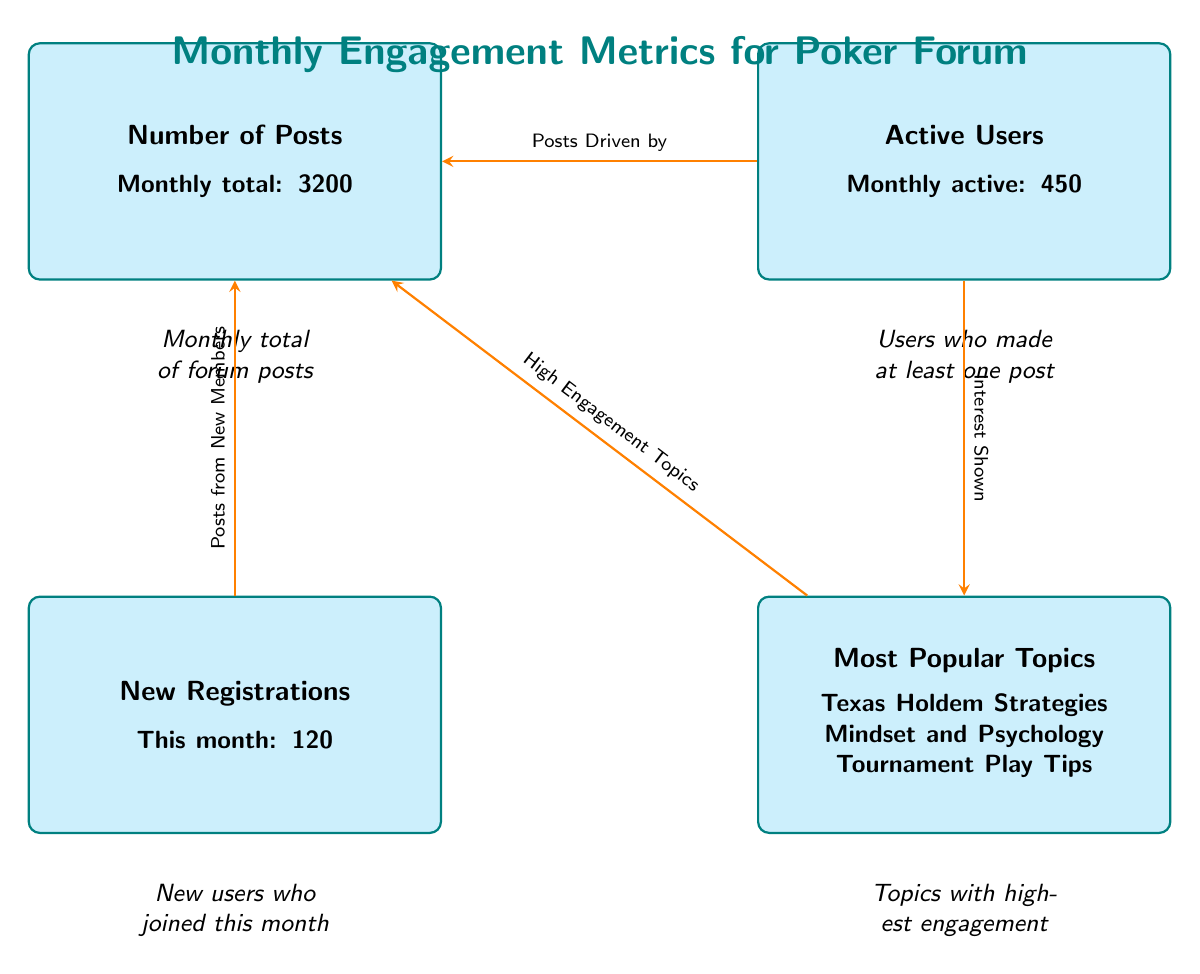What is the monthly total number of forum posts? The diagram states that the total number of posts is explicitly mentioned as "Monthly total: 3200" under the Number of Posts node.
Answer: 3200 How many active users participated this month? Under the Active Users node, it is clearly stated "Monthly active: 450," indicating the number of users who made posts.
Answer: 450 How many new registrations were reported this month? The New Registrations node shows "This month: 120," which provides the specific count of new members who joined the forum.
Answer: 120 What are the most popular topics indicated in the diagram? The Most Popular Topics node lists three entries: "Texas Holdem Strategies," "Mindset and Psychology," and "Tournament Play Tips." These represent the topics receiving the highest engagement.
Answer: Texas Holdem Strategies, Mindset and Psychology, Tournament Play Tips What relationship does the arrow from users to posts represent? The diagram illustrates that the arrow from Active Users to Number of Posts signifies that the posts are driven by the users' activity. This is explicitly noted in the text beside the arrow: "Posts Driven by."
Answer: Posts Driven by What impact do new registrations have on the number of posts? The arrow from New Registrations to Number of Posts indicates that posts from new members contribute to the overall number of posts, as described in "Posts from New Members."
Answer: Posts from New Members Which factors show interest in popular topics? The arrow from Active Users to Most Popular Topics indicates that users show interest in the topics, as noted in "Interest Shown." Thus, active users influence which topics are most popular.
Answer: Interest Shown How many nodes are present in the diagram? There are four main data nodes in the diagram: Number of Posts, Active Users, New Registrations, and Most Popular Topics. Each node represents a different engagement metric.
Answer: 4 How is high engagement correlated to the number of posts? The arrow from Most Popular Topics to Number of Posts signifies that high engagement topics lead to an increased number of posts, as noted "High Engagement Topics." Thus, these topics drive more engagement on the forum.
Answer: High Engagement Topics 